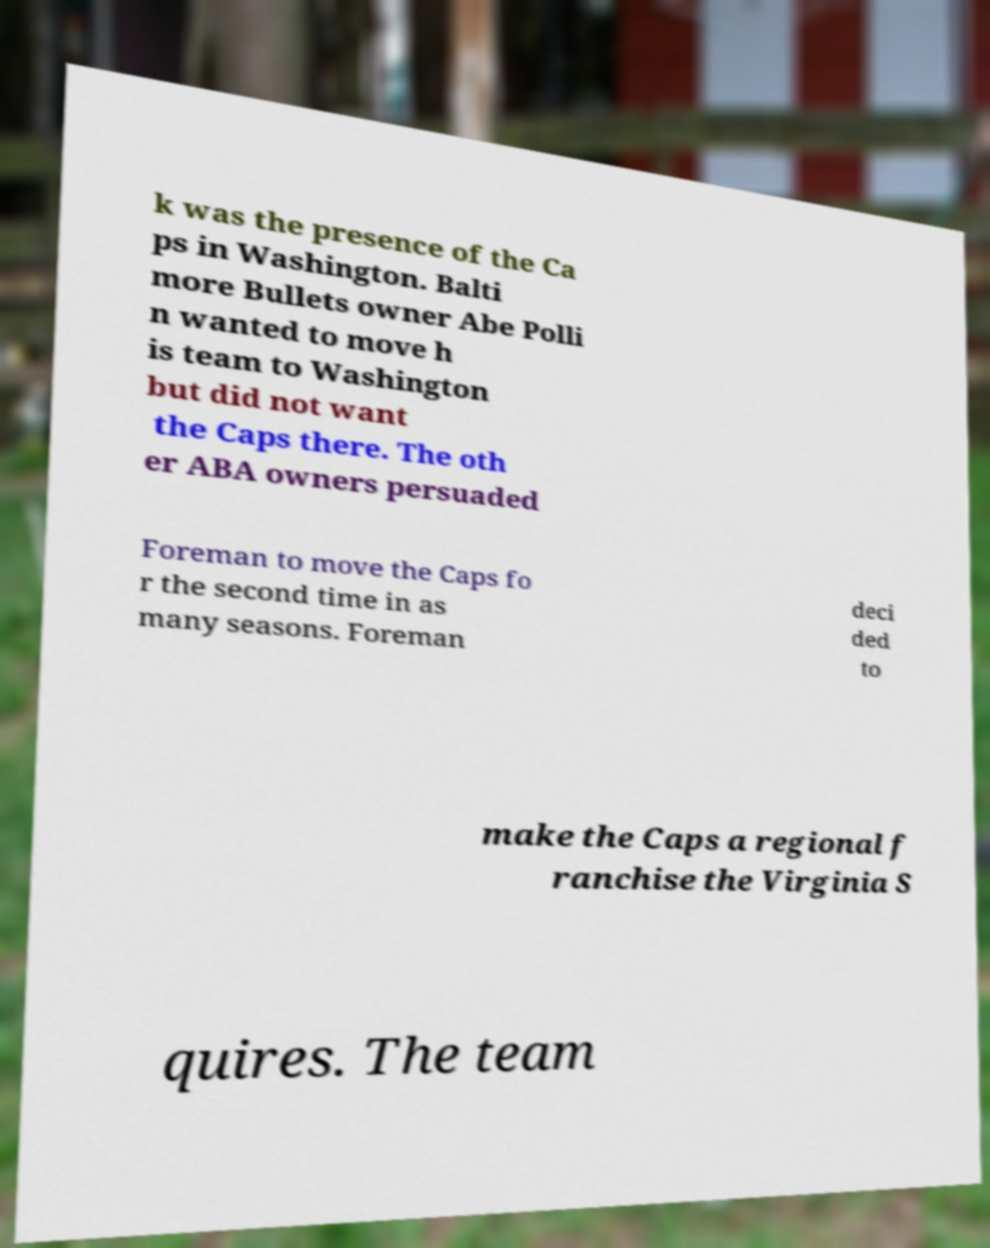What messages or text are displayed in this image? I need them in a readable, typed format. k was the presence of the Ca ps in Washington. Balti more Bullets owner Abe Polli n wanted to move h is team to Washington but did not want the Caps there. The oth er ABA owners persuaded Foreman to move the Caps fo r the second time in as many seasons. Foreman deci ded to make the Caps a regional f ranchise the Virginia S quires. The team 